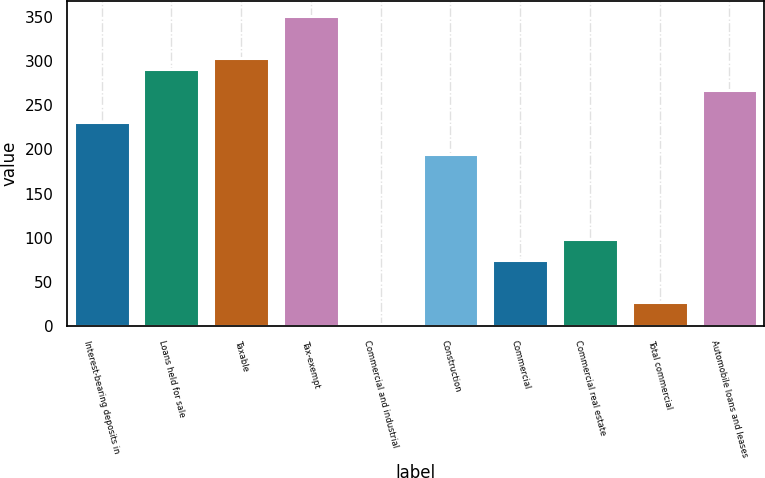<chart> <loc_0><loc_0><loc_500><loc_500><bar_chart><fcel>Interest-bearing deposits in<fcel>Loans held for sale<fcel>Taxable<fcel>Tax-exempt<fcel>Commercial and industrial<fcel>Construction<fcel>Commercial<fcel>Commercial real estate<fcel>Total commercial<fcel>Automobile loans and leases<nl><fcel>231<fcel>291<fcel>303<fcel>351<fcel>3<fcel>195<fcel>75<fcel>99<fcel>27<fcel>267<nl></chart> 